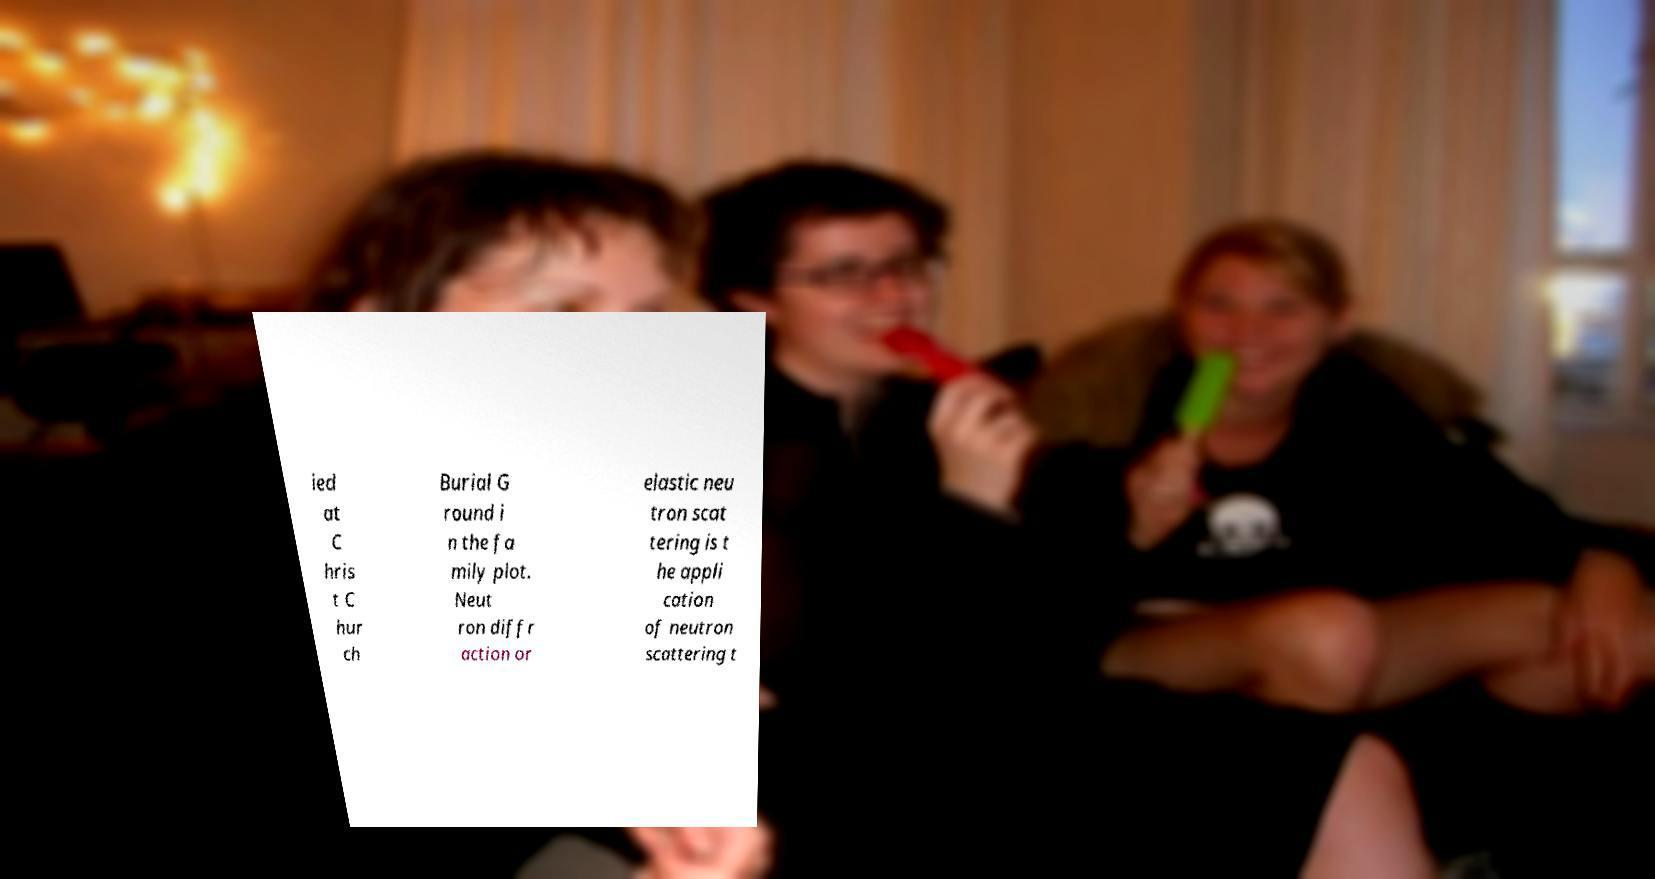For documentation purposes, I need the text within this image transcribed. Could you provide that? ied at C hris t C hur ch Burial G round i n the fa mily plot. Neut ron diffr action or elastic neu tron scat tering is t he appli cation of neutron scattering t 